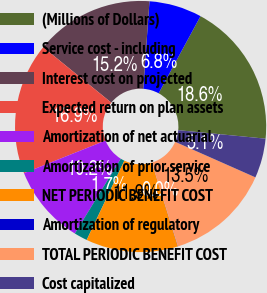<chart> <loc_0><loc_0><loc_500><loc_500><pie_chart><fcel>(Millions of Dollars)<fcel>Service cost - including<fcel>Interest cost on projected<fcel>Expected return on plan assets<fcel>Amortization of net actuarial<fcel>Amortization of prior service<fcel>NET PERIODIC BENEFIT COST<fcel>Amortization of regulatory<fcel>TOTAL PERIODIC BENEFIT COST<fcel>Cost capitalized<nl><fcel>18.63%<fcel>6.79%<fcel>15.25%<fcel>16.94%<fcel>10.17%<fcel>1.71%<fcel>11.86%<fcel>0.02%<fcel>13.55%<fcel>5.09%<nl></chart> 